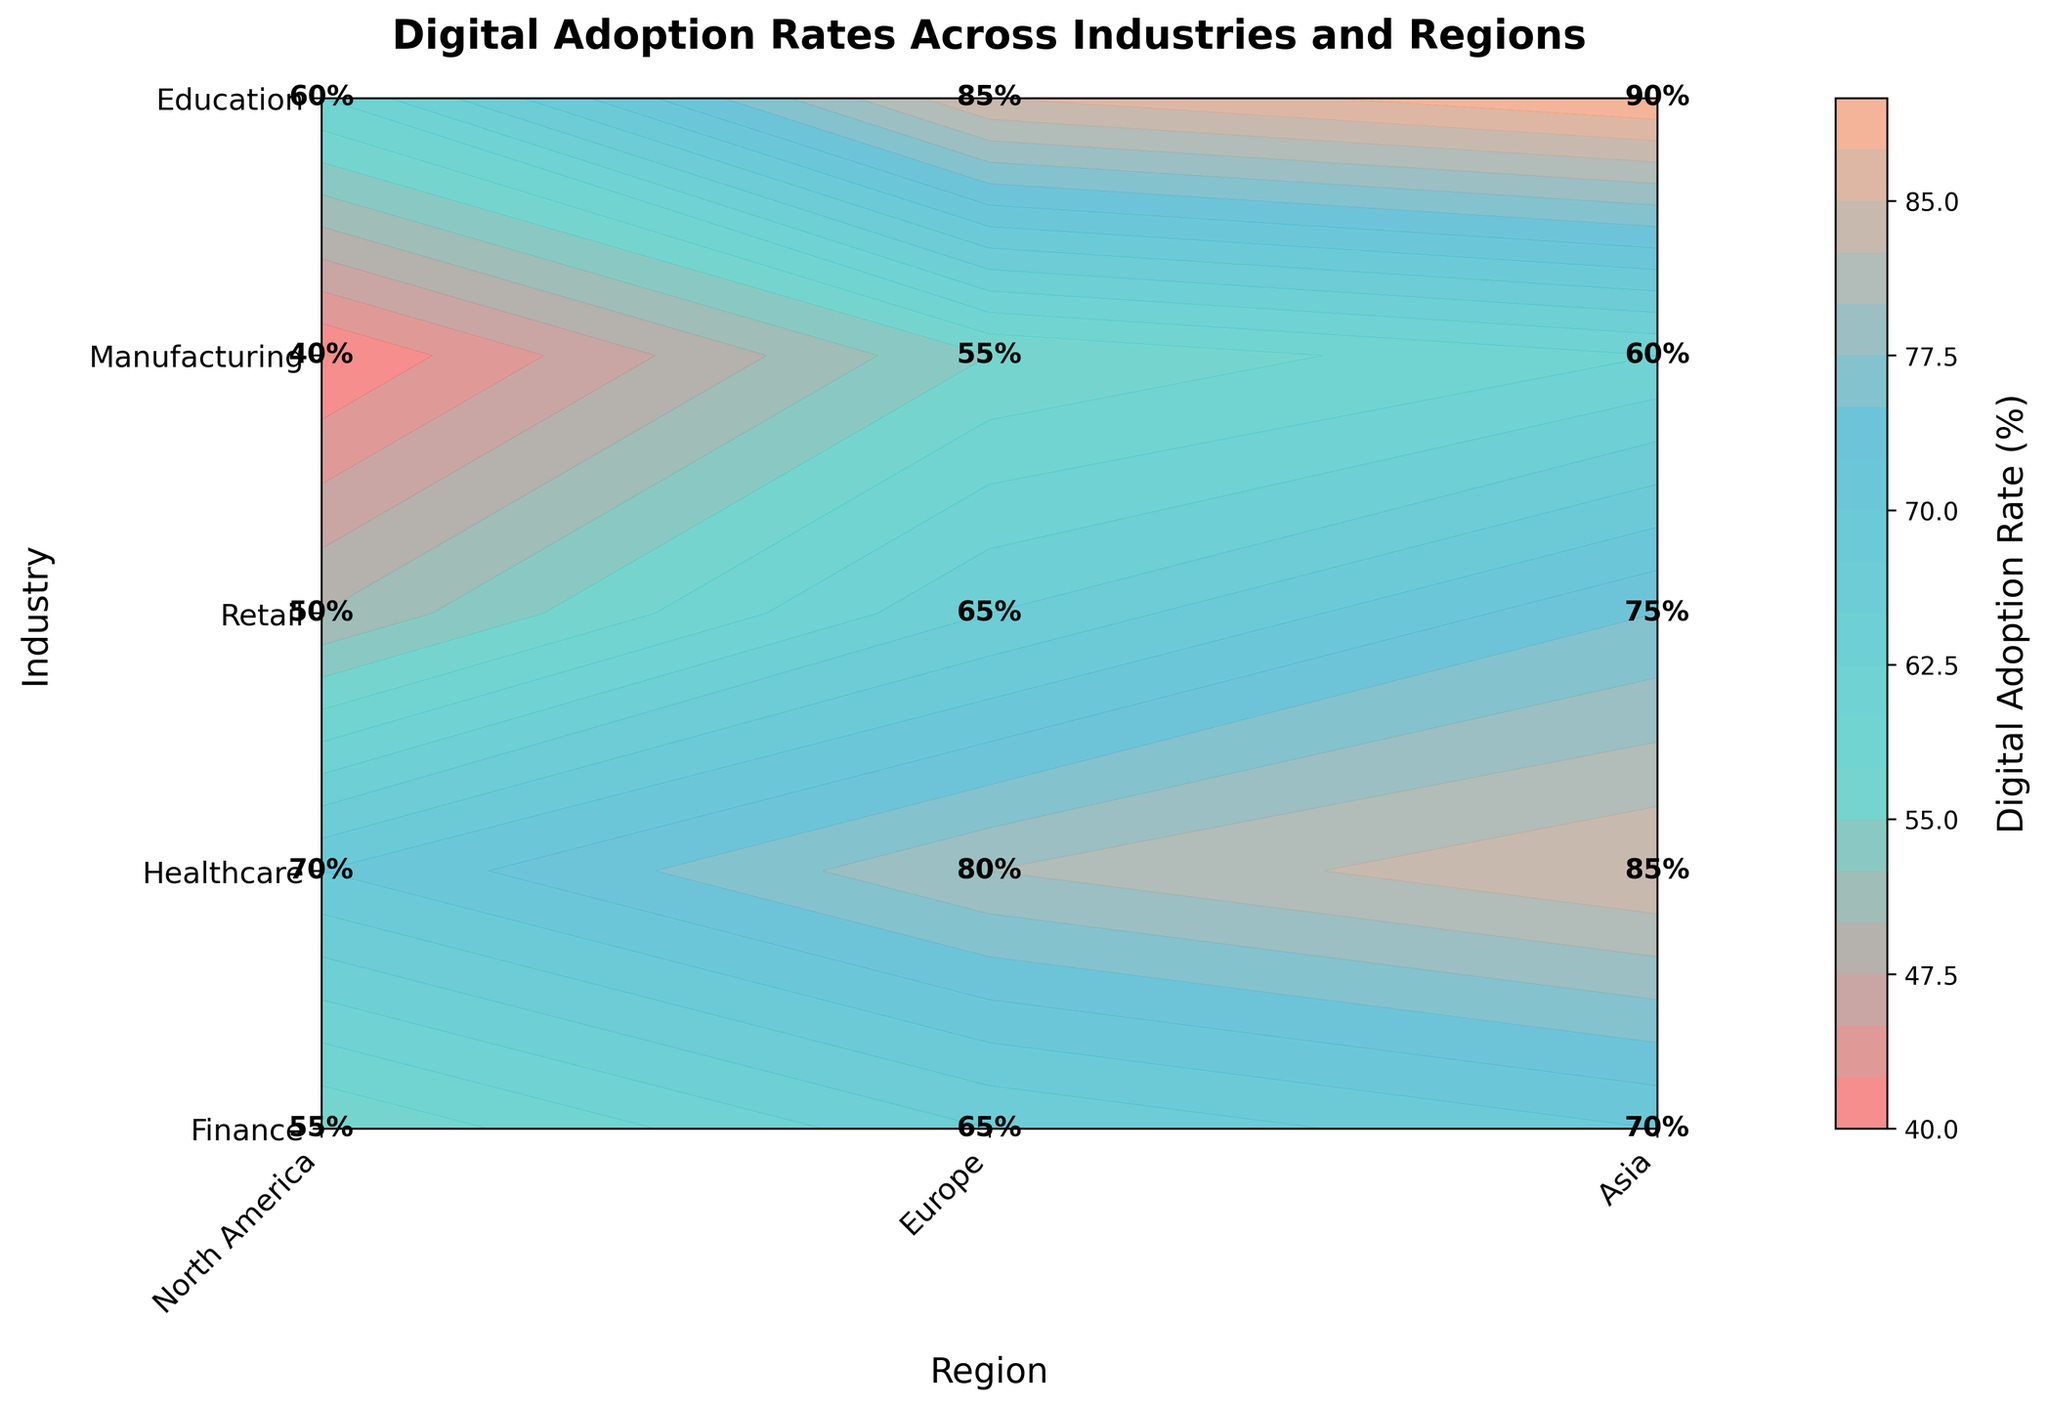What is the title of the figure? The title of the figure is displayed at the top. It reads "Digital Adoption Rates Across Industries and Regions".
Answer: Digital Adoption Rates Across Industries and Regions Which region has the highest digital adoption rate in the Retail industry? The Retail industry row shows rates of 90% for North America, which is the highest compared to Europe (85%) and Asia (60%).
Answer: North America What is the digital adoption rate for Healthcare in Asia? Locate the intersection of the Healthcare row and the Asia column where the rate is labeled.
Answer: 50% Which industry in Europe has the lowest digital adoption rate? By comparing the values in the Europe column across all industries, Manufacturing has the lowest rate at 55%.
Answer: Manufacturing What is the average digital adoption rate for the Finance industry across all regions? Add the rates for North America (85%), Europe (80%), and Asia (70%) and then divide by 3. (85 + 80 + 70) / 3 = 78.33
Answer: 78.33 Which region shows the highest digital adoption rate among all the industries? By comparing the highest percentages in each region's column, North America-Retail has the highest at 90%.
Answer: North America Which industry has the smallest difference in digital adoption rates between Europe and North America? Calculate differences between North America and Europe for each industry: Finance (85-80=5), Healthcare (75-65=10), Retail (90-85=5), Manufacturing (60-55=5), Education (70-65=5). The Finance, Retail, Manufacturing, and Education industries all have a difference of 5, which is the smallest.
Answer: Multiple (Finance, Retail, Manufacturing, Education) Are there any industries where the digital adoption rate is equal across two different regions? Check for rows where two out of three values are identical. No industry has equal rates across two regions.
Answer: No In which region does the Education industry show a higher digital adoption rate than the Finance industry? Compare the Education and Finance rates across all regions. In Asia, Education (55%) is higher than Finance (50%).
Answer: Asia What's the median digital adoption rate in Asia across all industries? Arrange the adoption rates in Asia (70, 50, 60, 40, 55) and find the median. The middle value is 55.
Answer: 55 